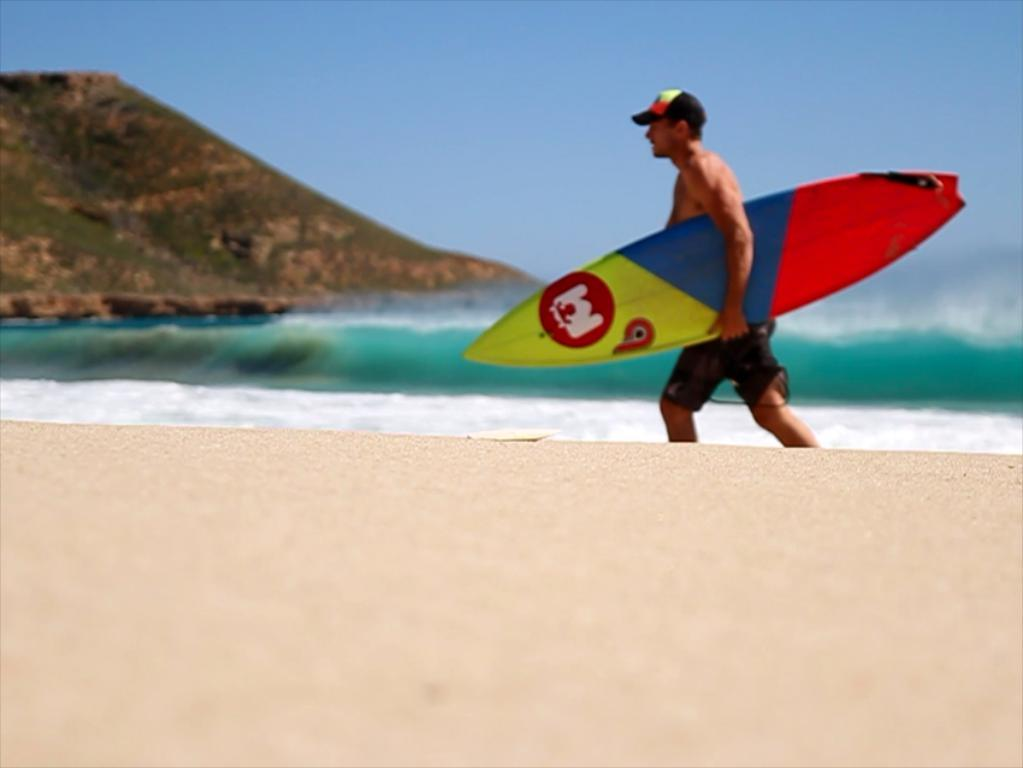Who is present in the image? There is a man in the image. What is the man holding in the image? The man is holding a surfboard. What can be seen in the background of the image? There is water and hills visible in the background of the image. What type of paste can be seen on the surfboard in the image? There is no paste visible on the surfboard in the image. Are there any jellyfish swimming in the water in the image? There is no mention of jellyfish in the image, only water and hills in the background. 